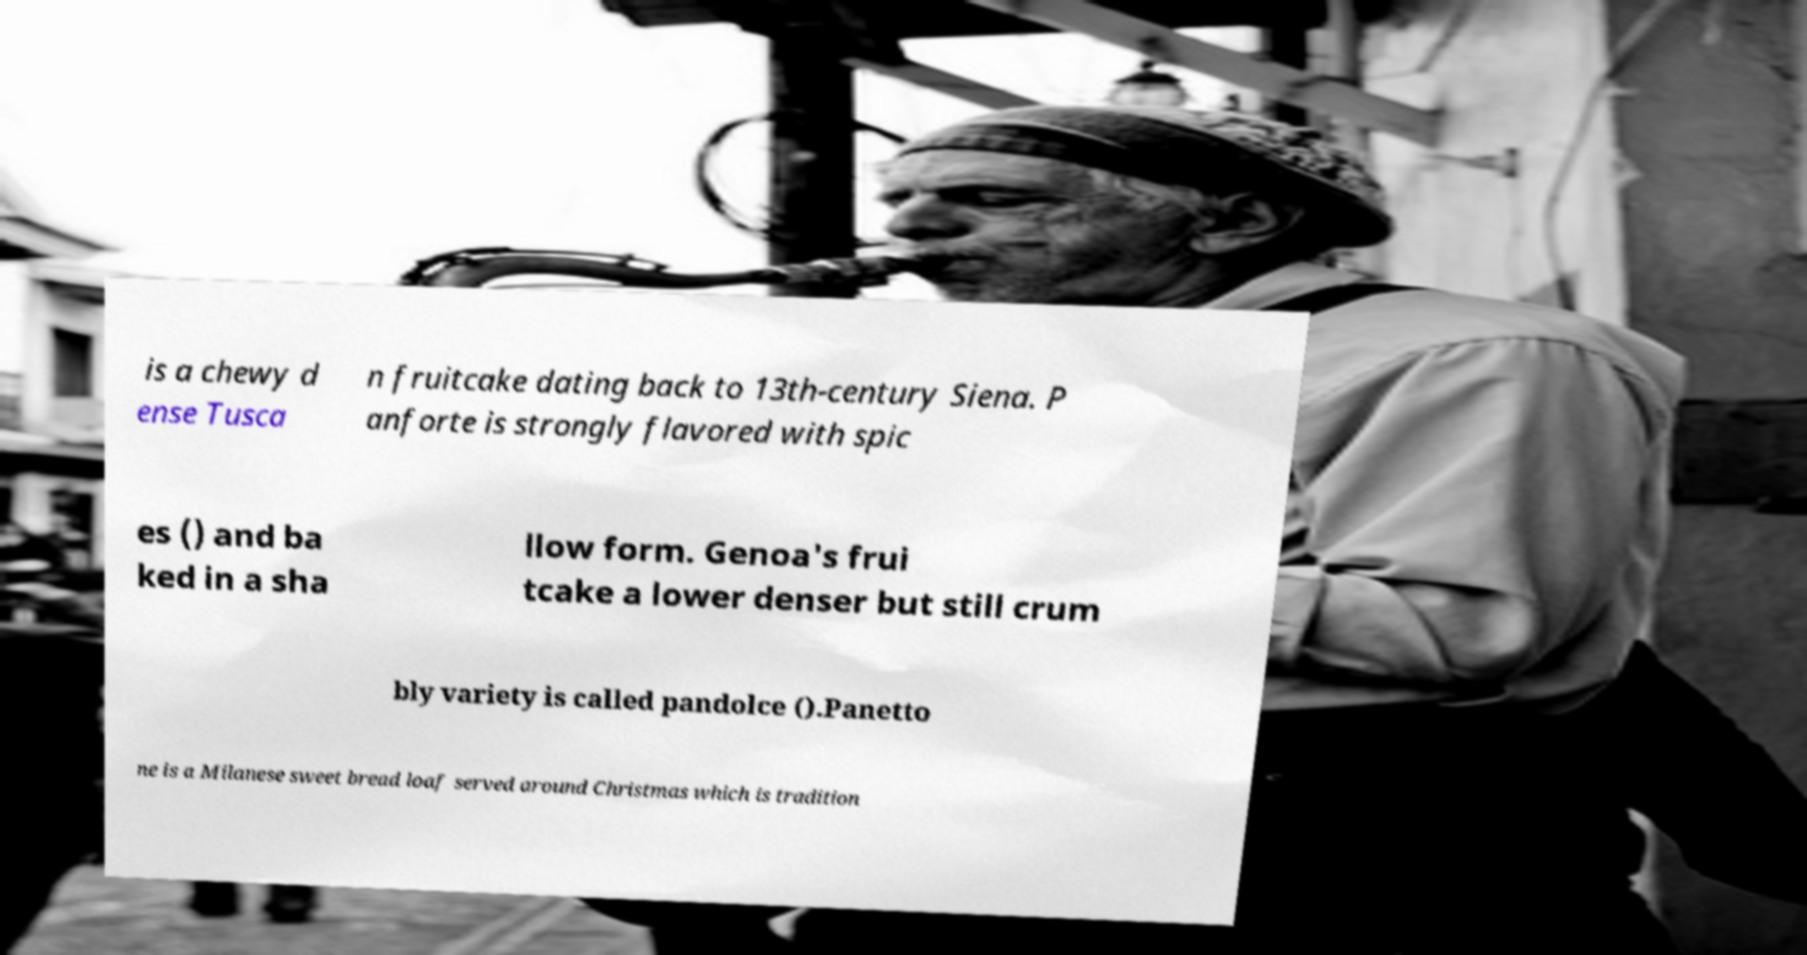Could you assist in decoding the text presented in this image and type it out clearly? is a chewy d ense Tusca n fruitcake dating back to 13th-century Siena. P anforte is strongly flavored with spic es () and ba ked in a sha llow form. Genoa's frui tcake a lower denser but still crum bly variety is called pandolce ().Panetto ne is a Milanese sweet bread loaf served around Christmas which is tradition 